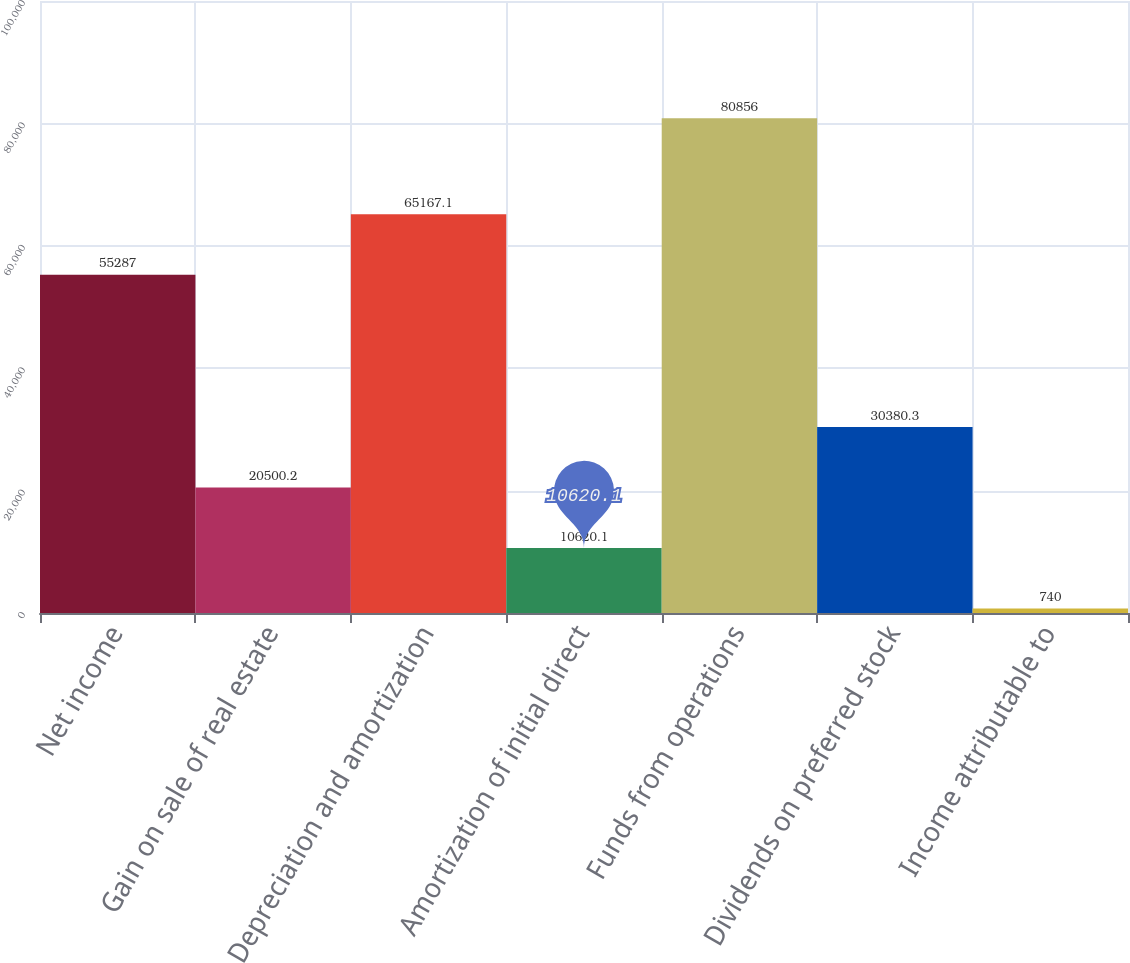Convert chart to OTSL. <chart><loc_0><loc_0><loc_500><loc_500><bar_chart><fcel>Net income<fcel>Gain on sale of real estate<fcel>Depreciation and amortization<fcel>Amortization of initial direct<fcel>Funds from operations<fcel>Dividends on preferred stock<fcel>Income attributable to<nl><fcel>55287<fcel>20500.2<fcel>65167.1<fcel>10620.1<fcel>80856<fcel>30380.3<fcel>740<nl></chart> 